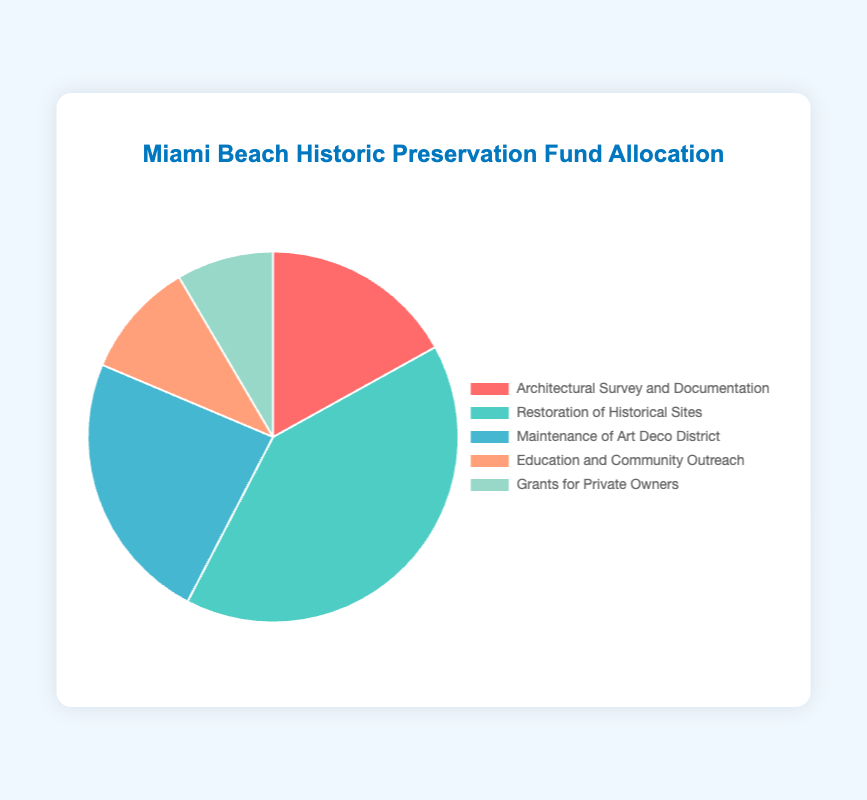Which category receives the largest portion of the budget? By looking at the pie chart, the largest segment represents the category with the highest allocation. The segment corresponding to "Restoration of Historical Sites" is the largest.
Answer: Restoration of Historical Sites Which category has the smallest budget allocation? The smallest segment in the pie chart represents the category with the lowest allocation. The segment for "Grants for Private Owners" is the smallest.
Answer: Grants for Private Owners How much more is allocated to Restoration of Historical Sites compared to Maintenance of Art Deco District? Restoration of Historical Sites has an allocation of $120,000 and Maintenance of Art Deco District has $70,000. The difference is $120,000 - $70,000 = $50,000.
Answer: $50,000 What is the combined budget for Architectural Survey and Documentation and Education and Community Outreach? The allocations for Architectural Survey and Documentation and Education and Community Outreach are $50,000 and $30,000, respectively. Their combined budget is $50,000 + $30,000 = $80,000.
Answer: $80,000 What percentage of the budget is allocated to Maintenance of Art Deco District? The total budget is the sum of all allocations: $50,000 + $120,000 + $70,000 + $30,000 + $25,000 = $295,000. The percentage for Maintenance of Art Deco District is ($70,000 / $295,000) * 100 ≈ 23.73%.
Answer: 23.73% How does the allocation for Education and Community Outreach compare to the allocation for Architectural Survey and Documentation? The allocation for Education and Community Outreach is $30,000, while for Architectural Survey and Documentation it is $50,000. Thus, Education and Community Outreach receives less funding compared to Architectural Survey and Documentation.
Answer: Less What is the average budget allocation across all categories? Sum of all allocations is $295,000. There are 5 categories. The average budget allocation is $295,000 / 5 = $59,000.
Answer: $59,000 Which category has a bigger allocation: Grants for Private Owners or Education and Community Outreach? By comparing the segments on the pie chart, it is evident that the allocation for Education and Community Outreach ($30,000) is larger than Grants for Private Owners ($25,000).
Answer: Education and Community Outreach What is the total budget allocation for categories related to historical sites (Architectural Survey and Documentation + Restoration of Historical Sites + Maintenance of Art Deco District)? The total budget for these categories is the sum of their allocations: $50,000 + $120,000 + $70,000 = $240,000.
Answer: $240,000 